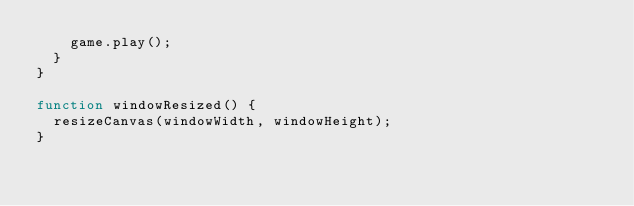<code> <loc_0><loc_0><loc_500><loc_500><_JavaScript_>    game.play();
  }
}

function windowResized() {
  resizeCanvas(windowWidth, windowHeight);
}
</code> 